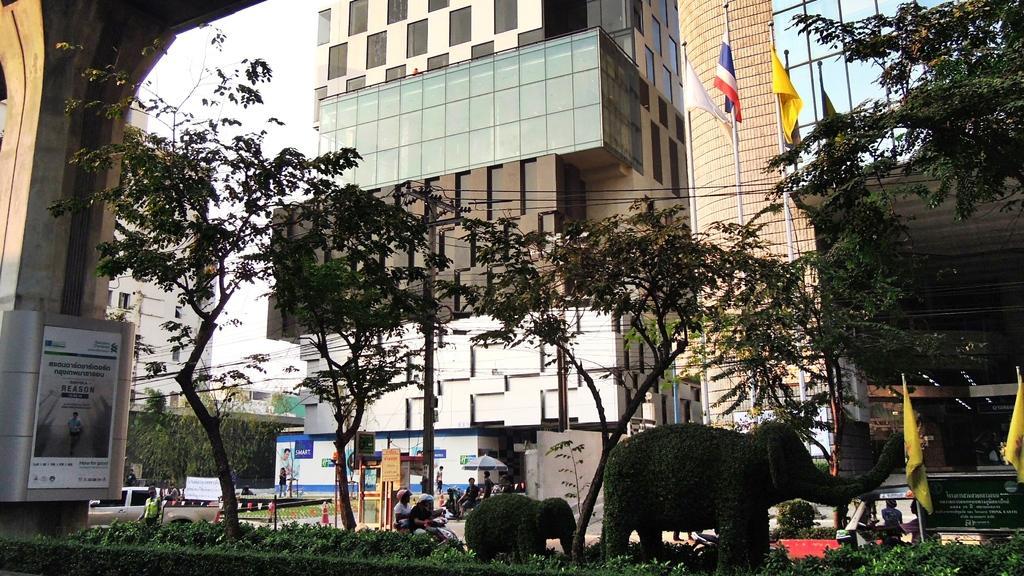Describe this image in one or two sentences. In this image there are plants, trees and two plants are in an elephant structure, in the background vehicles are moving on the road and there are flags, buildings, on the left side there is a pillar. 